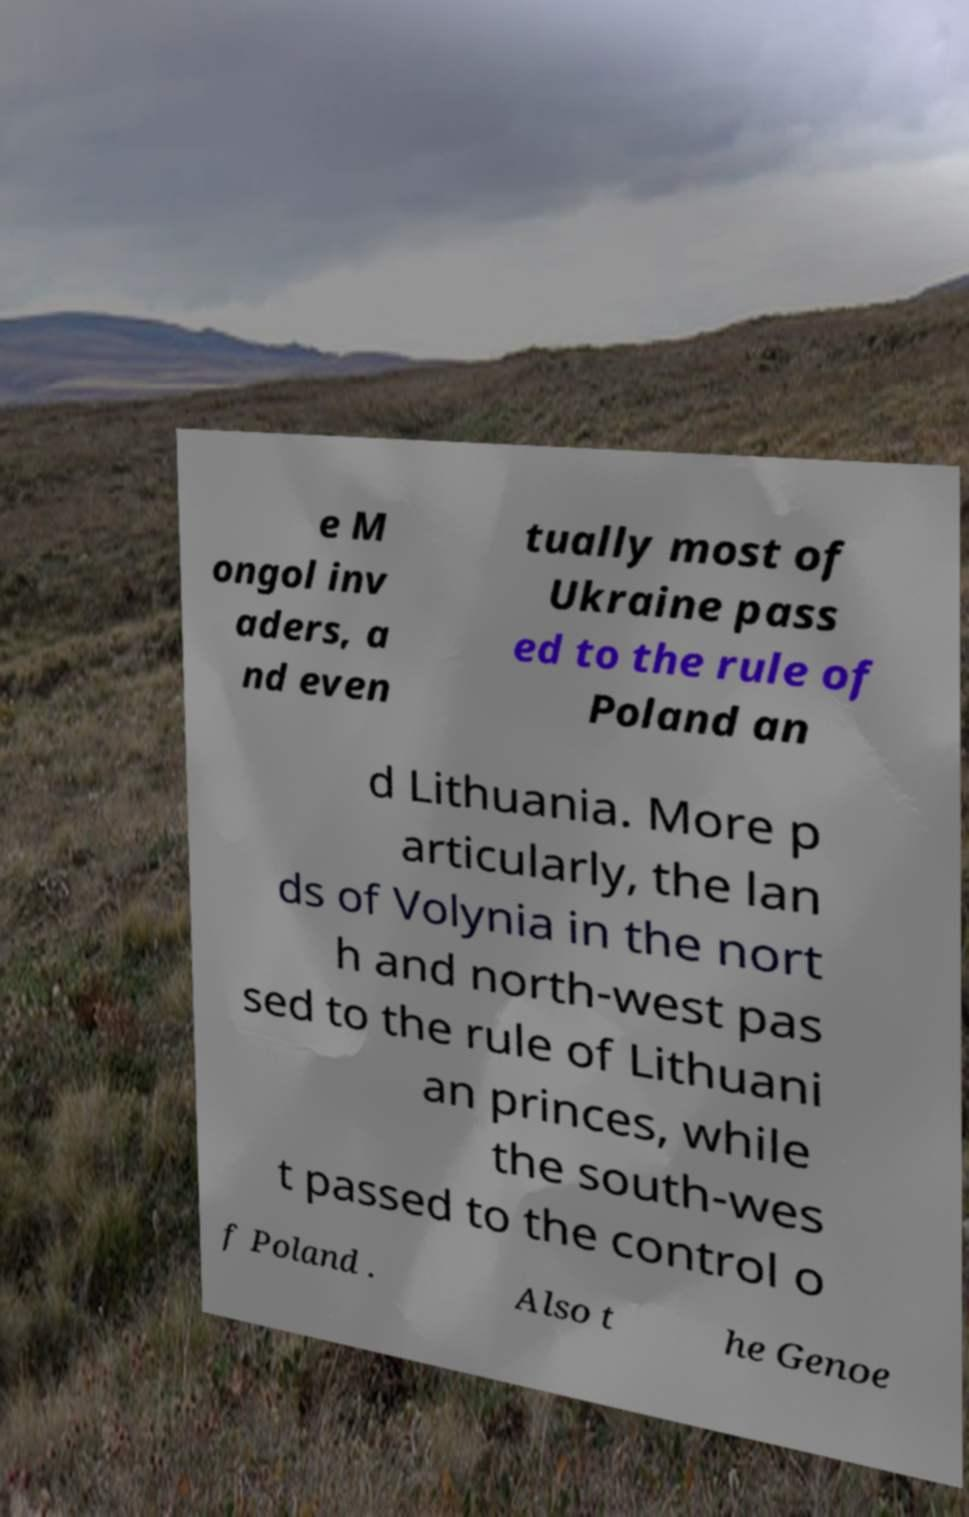Can you read and provide the text displayed in the image?This photo seems to have some interesting text. Can you extract and type it out for me? e M ongol inv aders, a nd even tually most of Ukraine pass ed to the rule of Poland an d Lithuania. More p articularly, the lan ds of Volynia in the nort h and north-west pas sed to the rule of Lithuani an princes, while the south-wes t passed to the control o f Poland . Also t he Genoe 